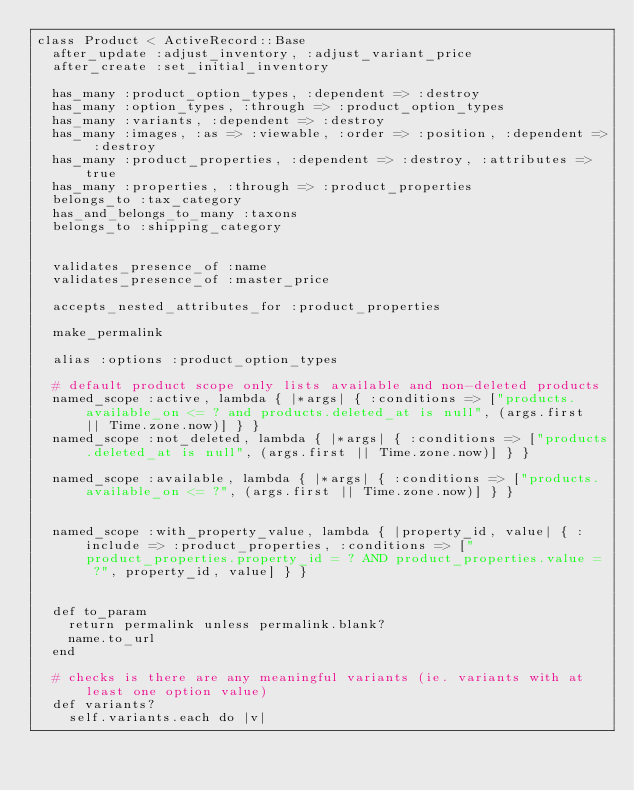<code> <loc_0><loc_0><loc_500><loc_500><_Ruby_>class Product < ActiveRecord::Base
  after_update :adjust_inventory, :adjust_variant_price
  after_create :set_initial_inventory
  
  has_many :product_option_types, :dependent => :destroy
  has_many :option_types, :through => :product_option_types
  has_many :variants, :dependent => :destroy
  has_many :images, :as => :viewable, :order => :position, :dependent => :destroy
  has_many :product_properties, :dependent => :destroy, :attributes => true
  has_many :properties, :through => :product_properties
  belongs_to :tax_category
  has_and_belongs_to_many :taxons
  belongs_to :shipping_category
  

  validates_presence_of :name
  validates_presence_of :master_price

  accepts_nested_attributes_for :product_properties
  
  make_permalink

  alias :options :product_option_types

  # default product scope only lists available and non-deleted products
  named_scope :active, lambda { |*args| { :conditions => ["products.available_on <= ? and products.deleted_at is null", (args.first || Time.zone.now)] } }
  named_scope :not_deleted, lambda { |*args| { :conditions => ["products.deleted_at is null", (args.first || Time.zone.now)] } }
  
  named_scope :available, lambda { |*args| { :conditions => ["products.available_on <= ?", (args.first || Time.zone.now)] } }


  named_scope :with_property_value, lambda { |property_id, value| { :include => :product_properties, :conditions => ["product_properties.property_id = ? AND product_properties.value = ?", property_id, value] } }

                 
  def to_param       
    return permalink unless permalink.blank?
    name.to_url
  end
  
  # checks is there are any meaningful variants (ie. variants with at least one option value)
  def variants?
    self.variants.each do |v|</code> 